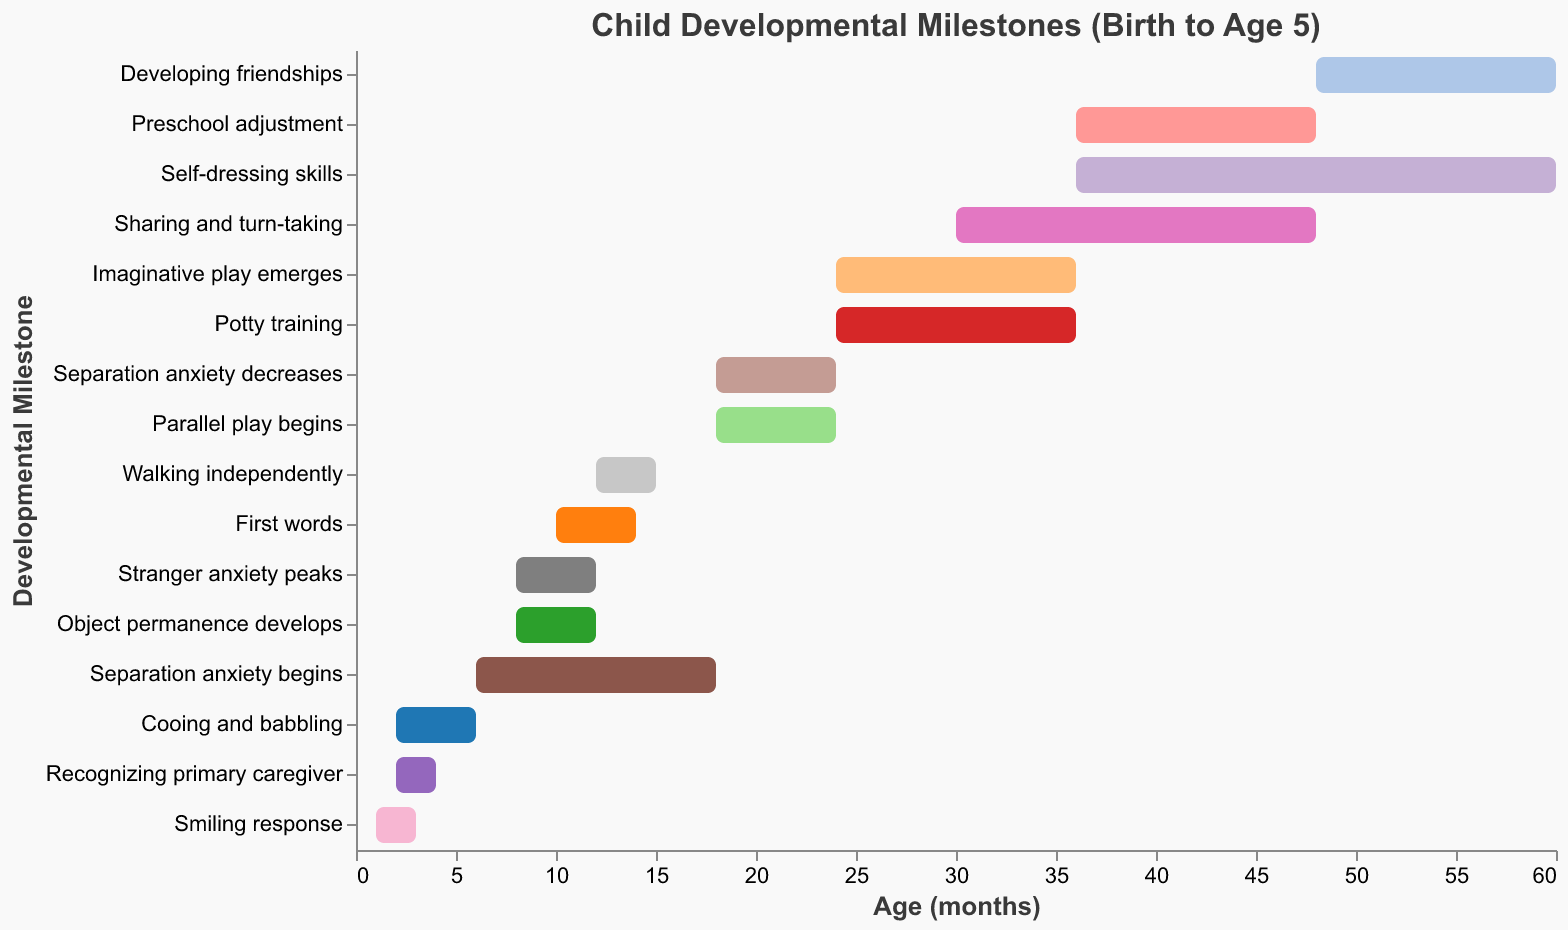When does the milestone "First words" typically start and end? The bar for "First words" starts at 10 months and ends at 14 months, based on the x-axis values.
Answer: 10 to 14 months Which milestones start at around 24 months? The bars corresponding to "Imaginative play emerges" and "Potty training" both start at 24 months according to their positions on the x-axis.
Answer: Imaginative play emerges, Potty training For how many months does the milestone "Parallel play begins" last? To find the duration, subtract the start age (18 months) from the end age (24 months): 24 - 18 = 6 months.
Answer: 6 months Which milestone has the longest duration and how long is it? "Self-dressing skills" starts at 36 months and ends at 60 months, spanning 60 - 36 = 24 months. This is the longest duration among the milestones.
Answer: Self-dressing skills, 24 months Which milestone overlaps in duration with "Stranger anxiety peaks"? "Object permanence develops" overlaps entirely with "Stranger anxiety peaks", as both run from 8 to 12 months.
Answer: Object permanence develops What is the difference in ending ages between "Walking independently" and "First words"? "Walking independently" ends at 15 months, while "First words" ends at 14 months. The difference is 15 - 14 = 1 month.
Answer: 1 month During which age range do both "Separation anxiety decreases" and "Parallel play begins" occur? Both milestones span from 18 to 24 months as shown by their bars on the x-axis.
Answer: 18 to 24 months Which milestones are associated with separation anxiety? The milestones related to separation anxiety are "Separation anxiety begins" (6-18 months) and "Separation anxiety decreases" (18-24 months).
Answer: Separation anxiety begins, Separation anxiety decreases If a child starts "Cooing and babbling" at 2 months, which other milestones are likely already started or starting in the same age range? "Recognizing primary caregiver" also starts at 2 months according to their bars on the x-axis.
Answer: Recognizing primary caregiver At what age do "Developing friendships" start to appear and how long do they last? "Developing friendships" starts at 48 months and lasts until 60 months, so they span 60 - 48 = 12 months.
Answer: 48 months, 12 months 